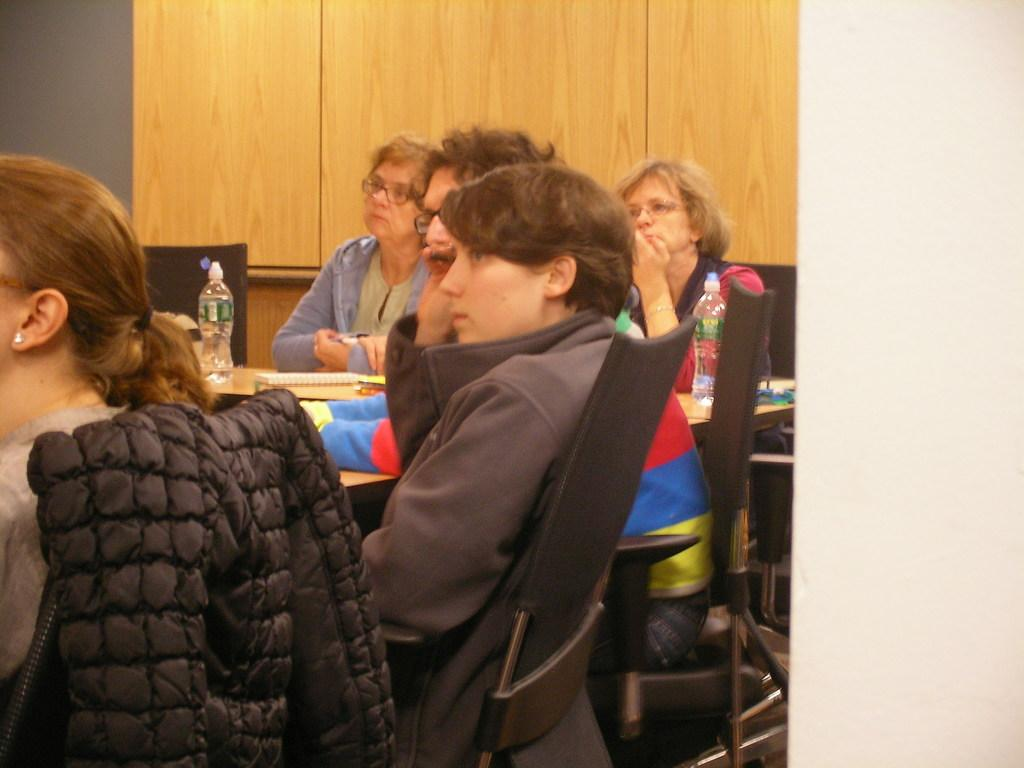How many people are present in the image? There are five people in the image. What are the people doing in the image? The people are sitting around a table. What objects can be seen on the table? There are bottles and books on the table. What type of magic trick is being performed by the people in the image? There is no indication of a magic trick being performed in the image; the people are simply sitting around a table. 